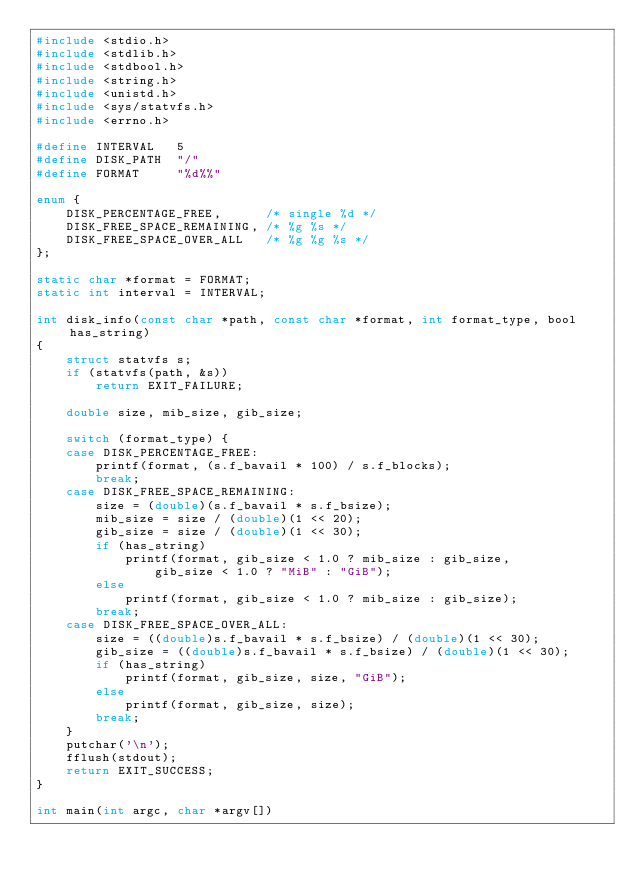Convert code to text. <code><loc_0><loc_0><loc_500><loc_500><_C_>#include <stdio.h>
#include <stdlib.h>
#include <stdbool.h>
#include <string.h>
#include <unistd.h>
#include <sys/statvfs.h>
#include <errno.h>

#define INTERVAL   5
#define DISK_PATH  "/"
#define FORMAT     "%d%%"

enum {
	DISK_PERCENTAGE_FREE,      /* single %d */
	DISK_FREE_SPACE_REMAINING, /* %g %s */
	DISK_FREE_SPACE_OVER_ALL   /* %g %g %s */
};

static char *format = FORMAT;
static int interval = INTERVAL;

int disk_info(const char *path, const char *format, int format_type, bool has_string)
{
	struct statvfs s;
	if (statvfs(path, &s))
		return EXIT_FAILURE;
	
	double size, mib_size, gib_size;

	switch (format_type) {
	case DISK_PERCENTAGE_FREE:
		printf(format, (s.f_bavail * 100) / s.f_blocks);
		break;
	case DISK_FREE_SPACE_REMAINING:
		size = (double)(s.f_bavail * s.f_bsize);
		mib_size = size / (double)(1 << 20);		
		gib_size = size / (double)(1 << 30);
		if (has_string)
			printf(format, gib_size < 1.0 ? mib_size : gib_size,
				gib_size < 1.0 ? "MiB" : "GiB");
		else
			printf(format, gib_size < 1.0 ? mib_size : gib_size);
		break;
	case DISK_FREE_SPACE_OVER_ALL:
		size = ((double)s.f_bavail * s.f_bsize) / (double)(1 << 30);
		gib_size = ((double)s.f_bavail * s.f_bsize) / (double)(1 << 30);
		if (has_string)
			printf(format, gib_size, size, "GiB");
		else
			printf(format, gib_size, size);
		break;
	}
	putchar('\n');
	fflush(stdout);
	return EXIT_SUCCESS;
}

int main(int argc, char *argv[])</code> 